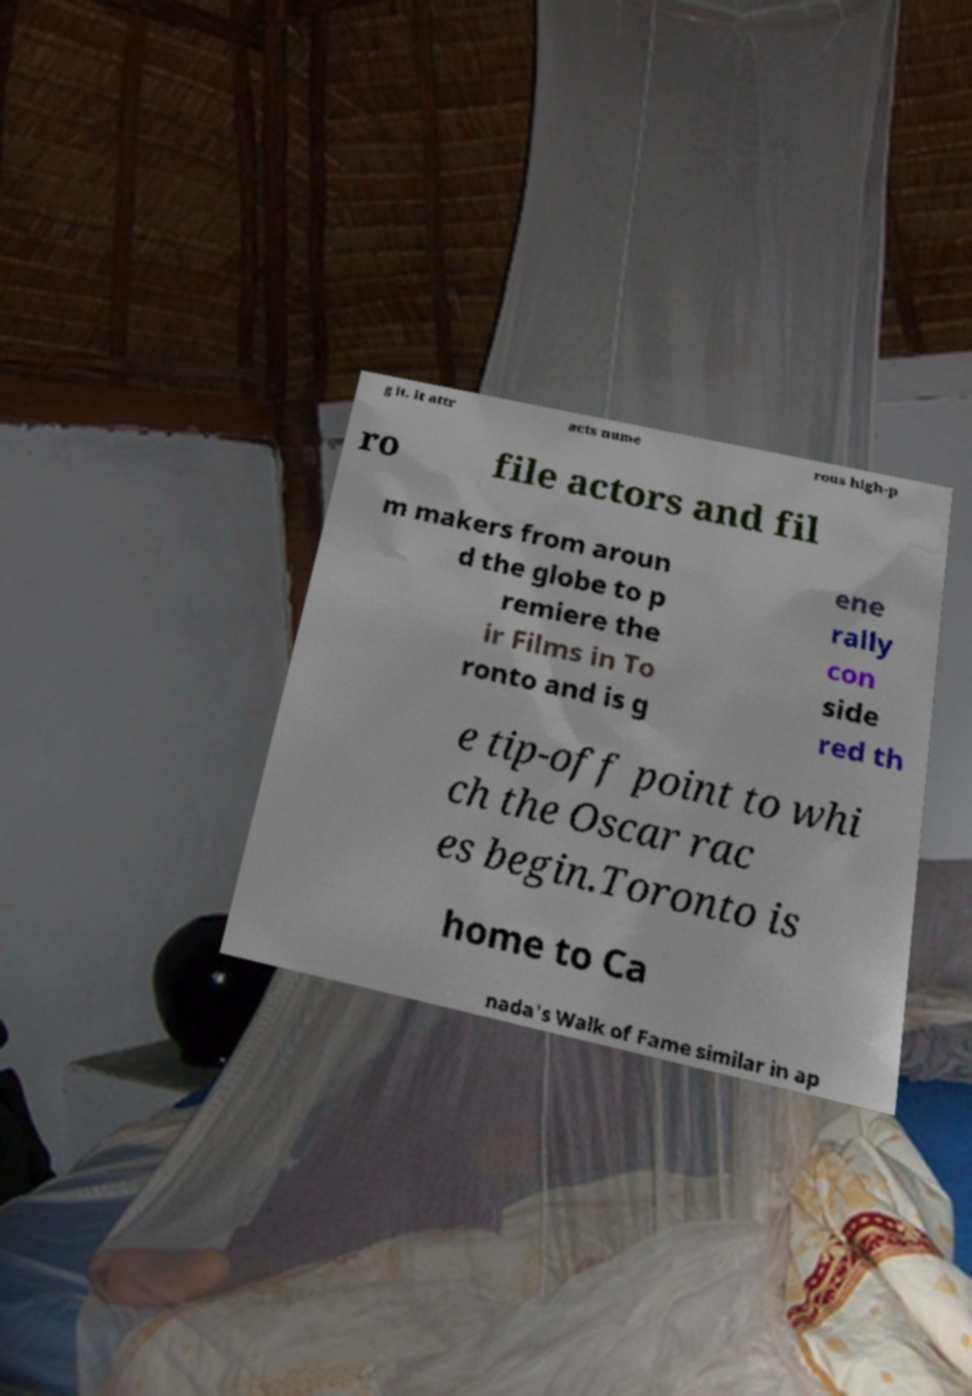Could you assist in decoding the text presented in this image and type it out clearly? g it. It attr acts nume rous high-p ro file actors and fil m makers from aroun d the globe to p remiere the ir Films in To ronto and is g ene rally con side red th e tip-off point to whi ch the Oscar rac es begin.Toronto is home to Ca nada's Walk of Fame similar in ap 